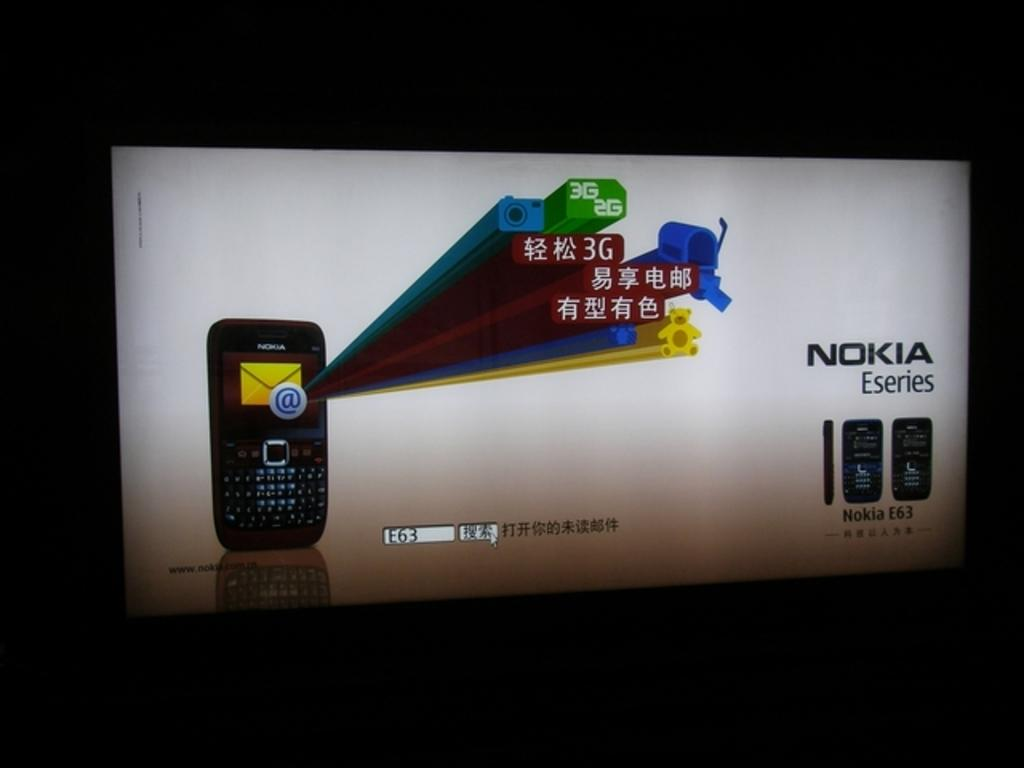<image>
Provide a brief description of the given image. A large flat screen TV shows a mobile phone ad that says Nokia Eseries. 